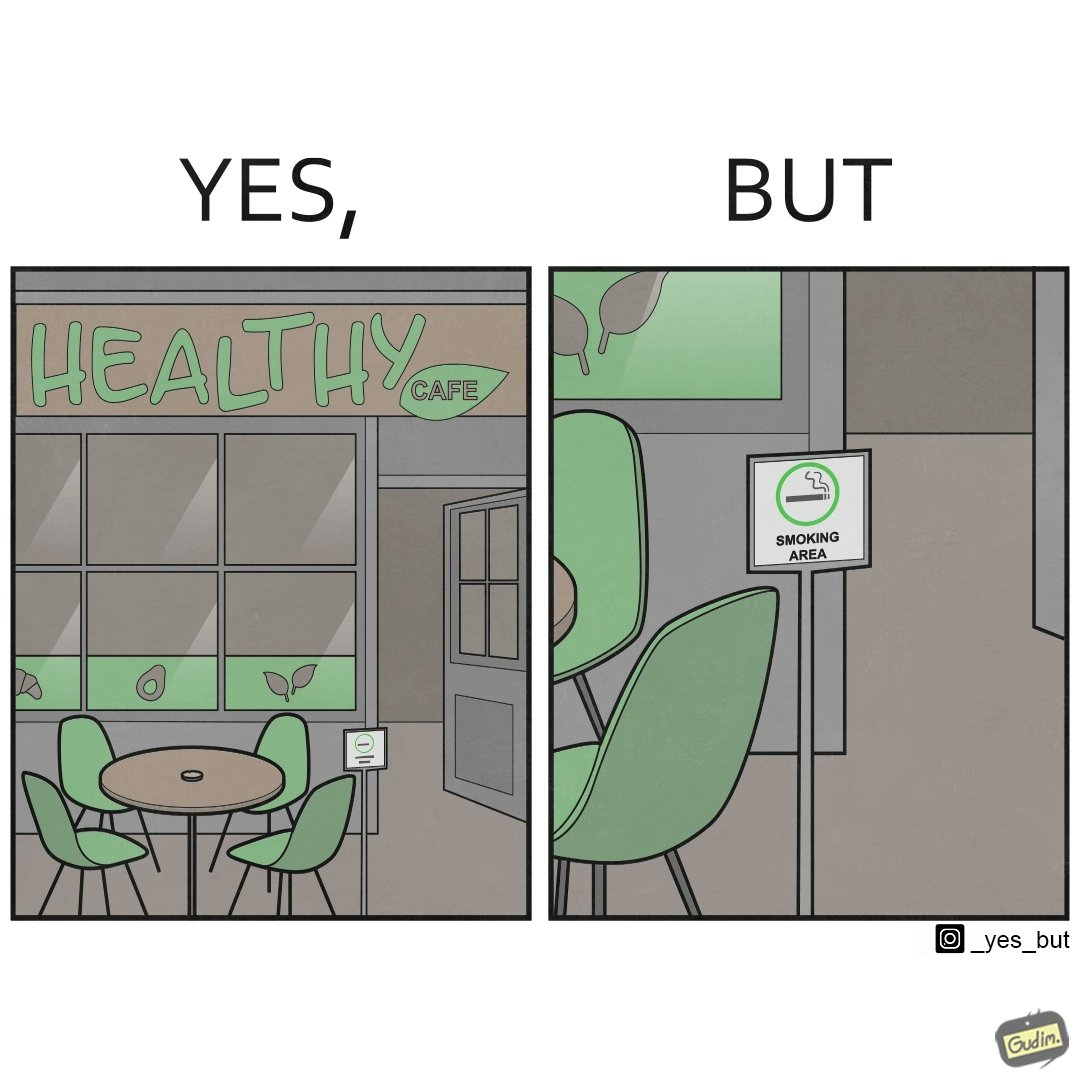Describe the contrast between the left and right parts of this image. In the left part of the image: An eatery with the name "Healthy Cafe". It has a green aesthetic with paintings of leaves, avocados, etc on their windows. They have an outdoor seating area with 4 green patio chairs around a circular table. There is a small sign on a stand near the table with a green circular symbol and some text that is too small to read. In the right part of the image: Green patio chairs. A sign on a stand that has a green circular symbol encircling a cigarette symbol, and some text that says "SMOKING AREA". 